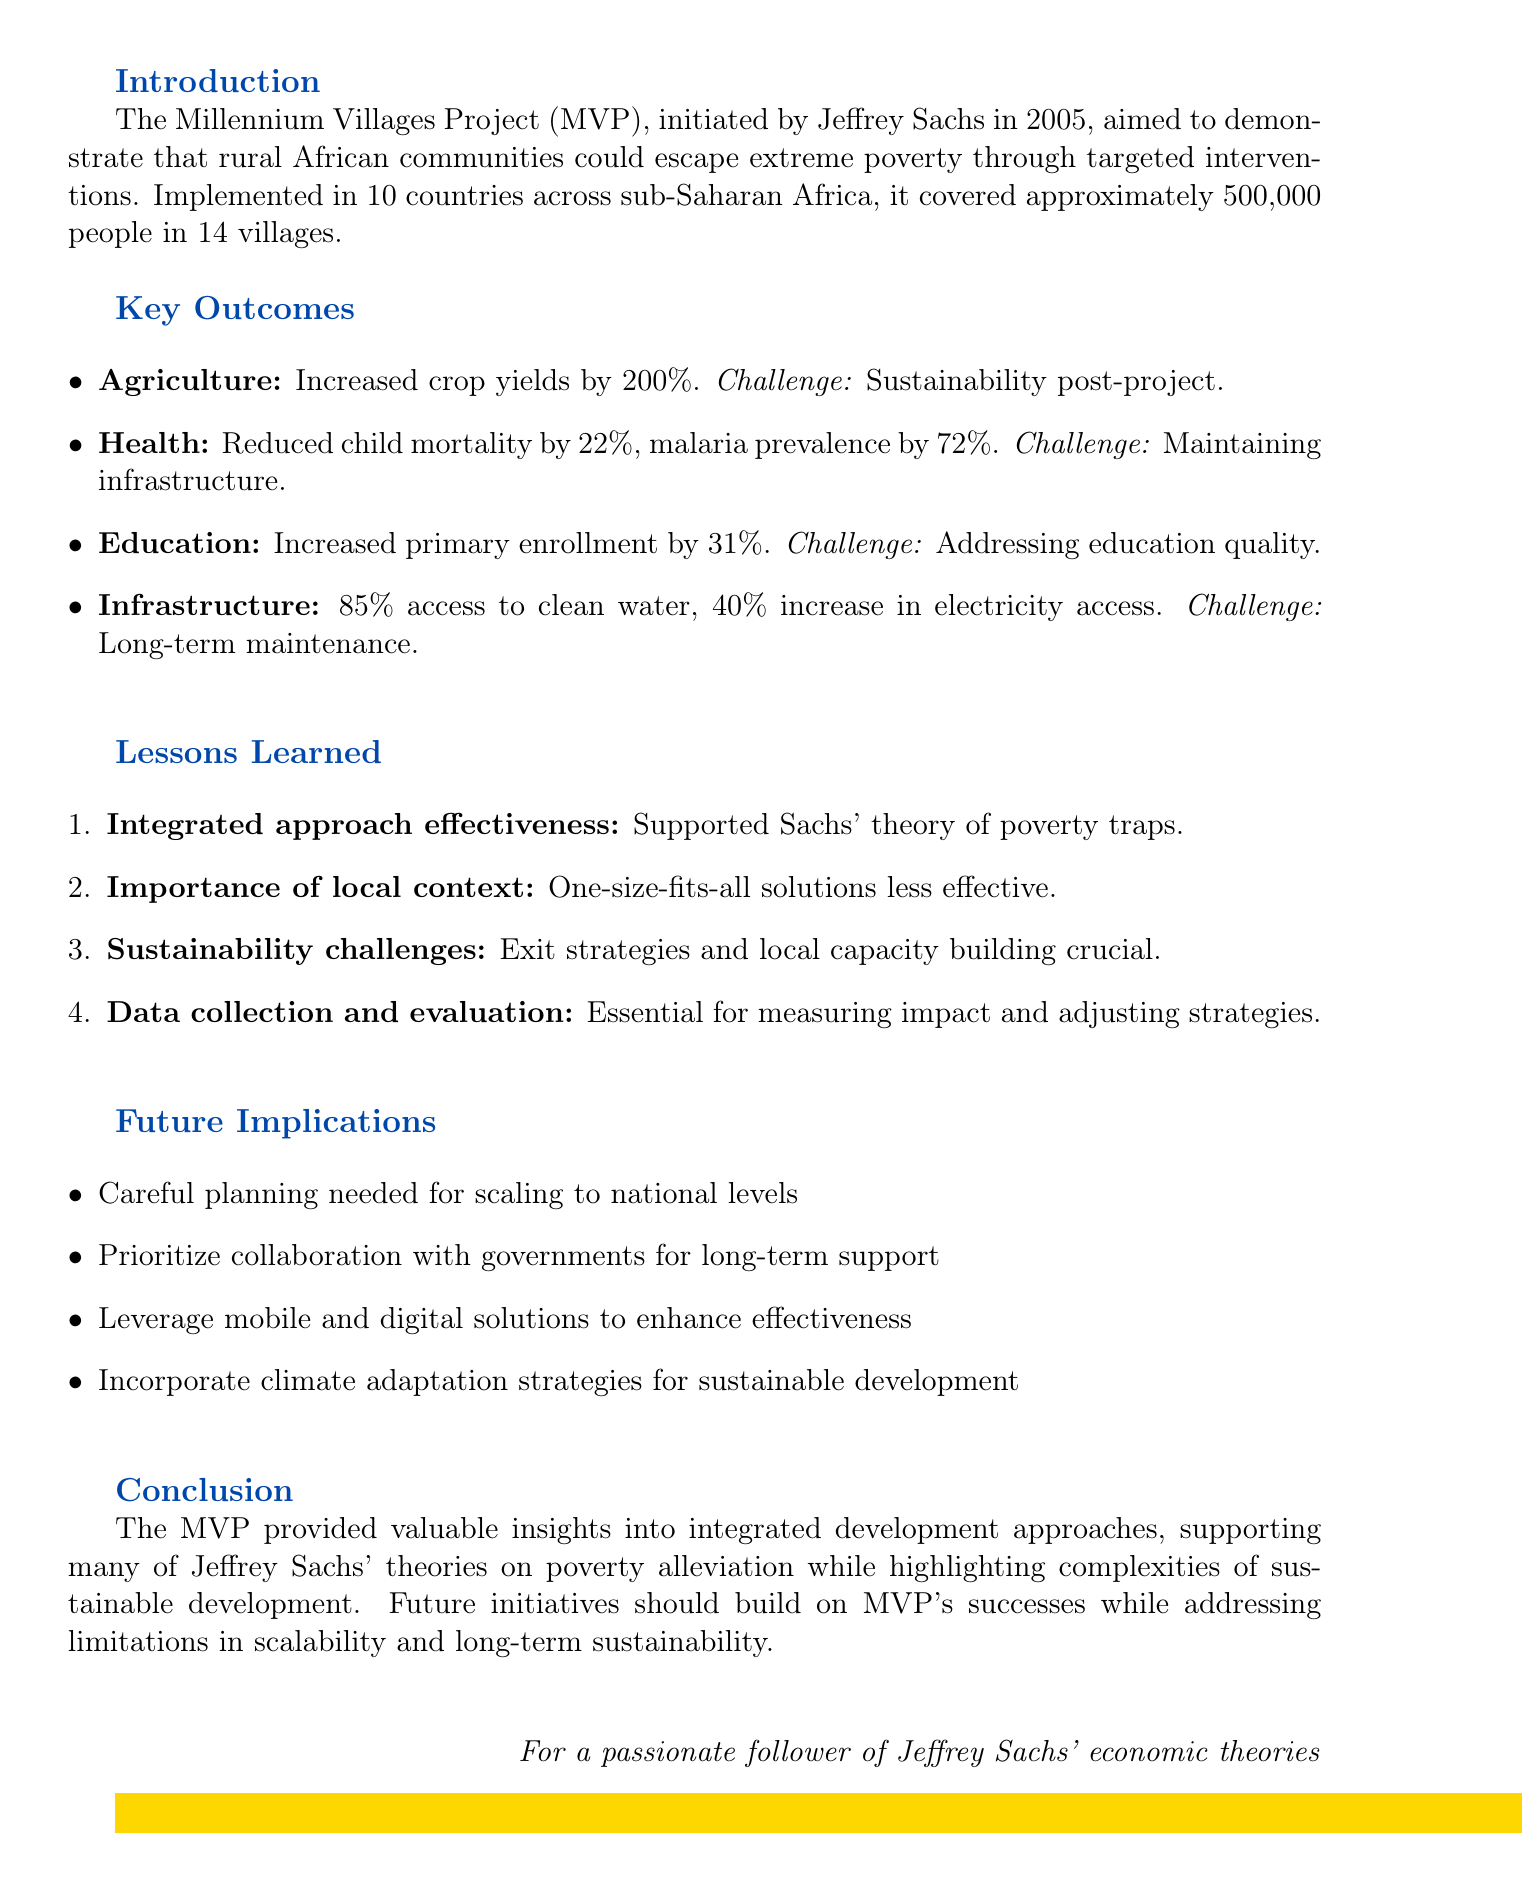What was the average increase in crop yields? The document states that crop yields increased by an average of 200% due to various interventions.
Answer: 200% How many countries were involved in the Millennium Villages Project? The project was implemented in 10 countries across sub-Saharan Africa.
Answer: 10 What percentage did child mortality rates reduce by? It is noted that child mortality rates were reduced by 22% as a result of the project's health initiatives.
Answer: 22% What was a significant challenge identified in the health outcomes? The memo mentions that maintaining health infrastructure and services without continued external funding is a major challenge.
Answer: Maintaining health infrastructure What lesson emphasizes the need for community-specific solutions? The document explains that one-size-fits-all solutions were less effective, highlighting the importance of addressing specific community needs.
Answer: Importance of local context What percentage of households gained access to clean water? According to the document, access to clean water improved for 85% of households in the Millennium Villages Project.
Answer: 85% Which approach demonstrated effectiveness according to the MVP? The integrated approach showed effectiveness in addressing multiple development goals simultaneously, supporting Sachs' theory on poverty traps.
Answer: Integrated approach effectiveness What should future initiatives prioritize for better outcomes? The document states that future initiatives should prioritize collaboration with national and local governments for long-term support.
Answer: Government partnerships What is a key aspect for ensuring sustainability after project support ends? The memo emphasizes that exit strategies and local capacity building are crucial for maintaining progress after external support ends.
Answer: Sustainability challenges 